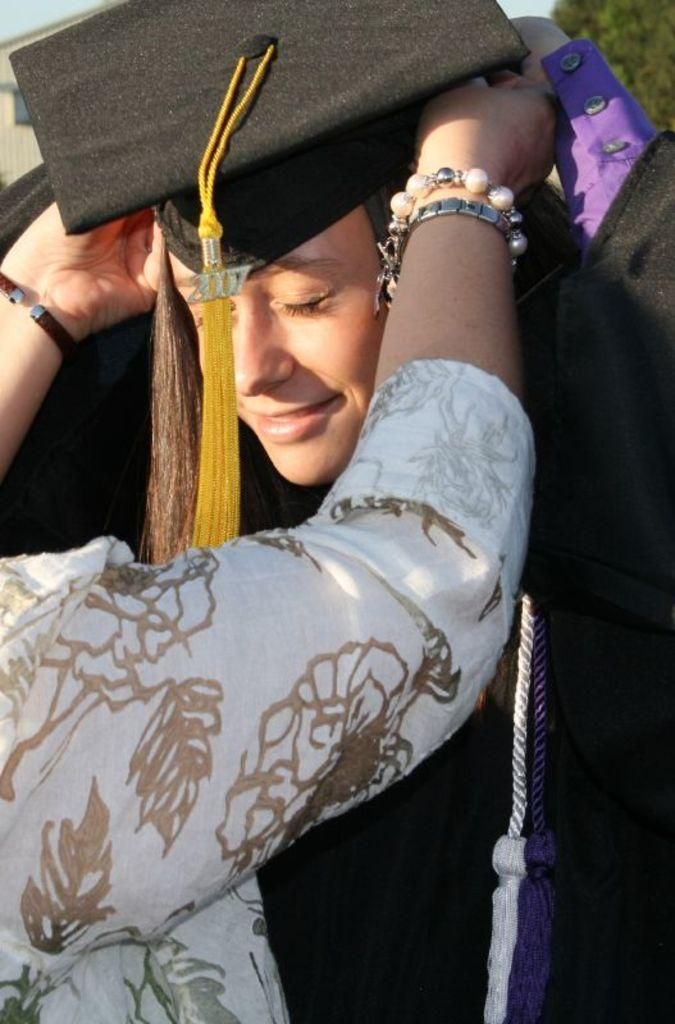Who is the main subject in the image? There is a woman in the image. What is the woman doing in the image? The woman is standing with her eyes closed. Is there anyone else in the image? Yes, there is a person in the image. What is the person doing in the image? The person is placing a graduation cap on the woman. What type of reaction can be seen from the copper in the image? There is no copper present in the image, so it is not possible to determine any reaction from it. 